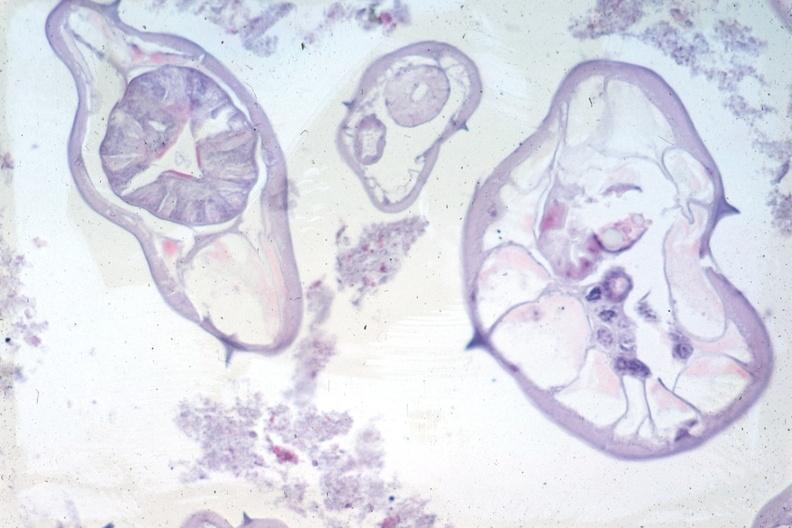does silver show organisms not appendix structures in photo?
Answer the question using a single word or phrase. No 